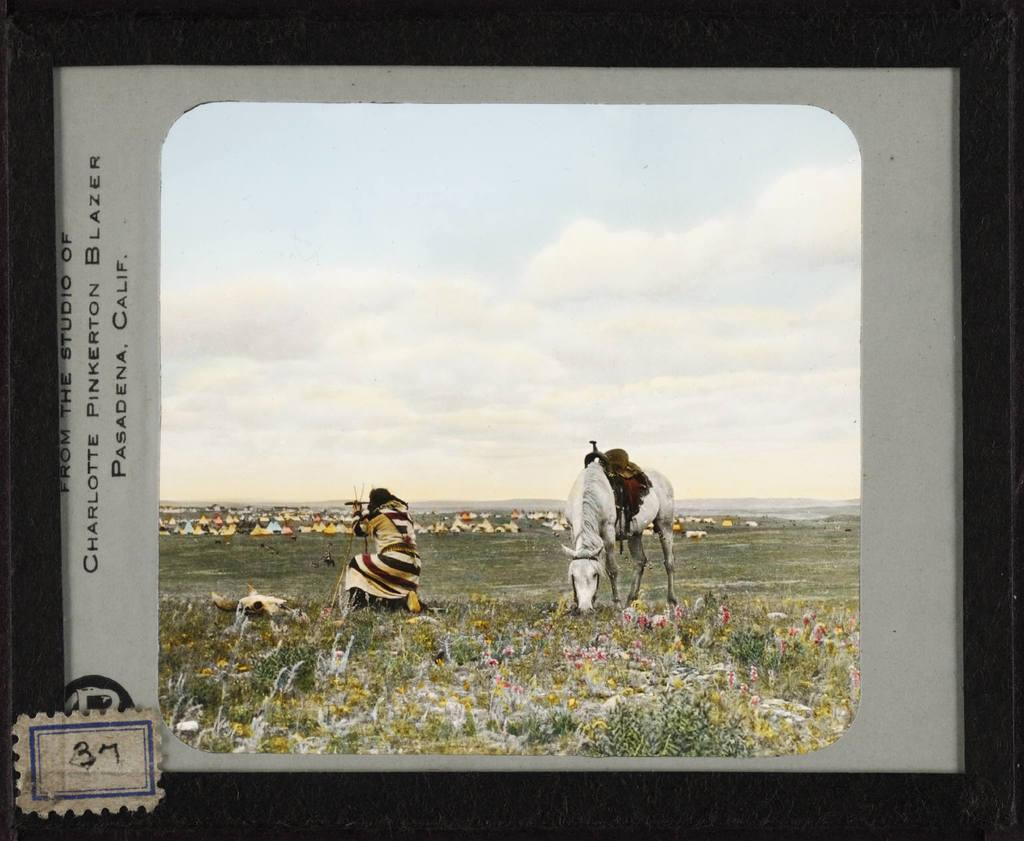<image>
Create a compact narrative representing the image presented. A postcard with a man and horse on it that is labeled Pasadena Calif. 